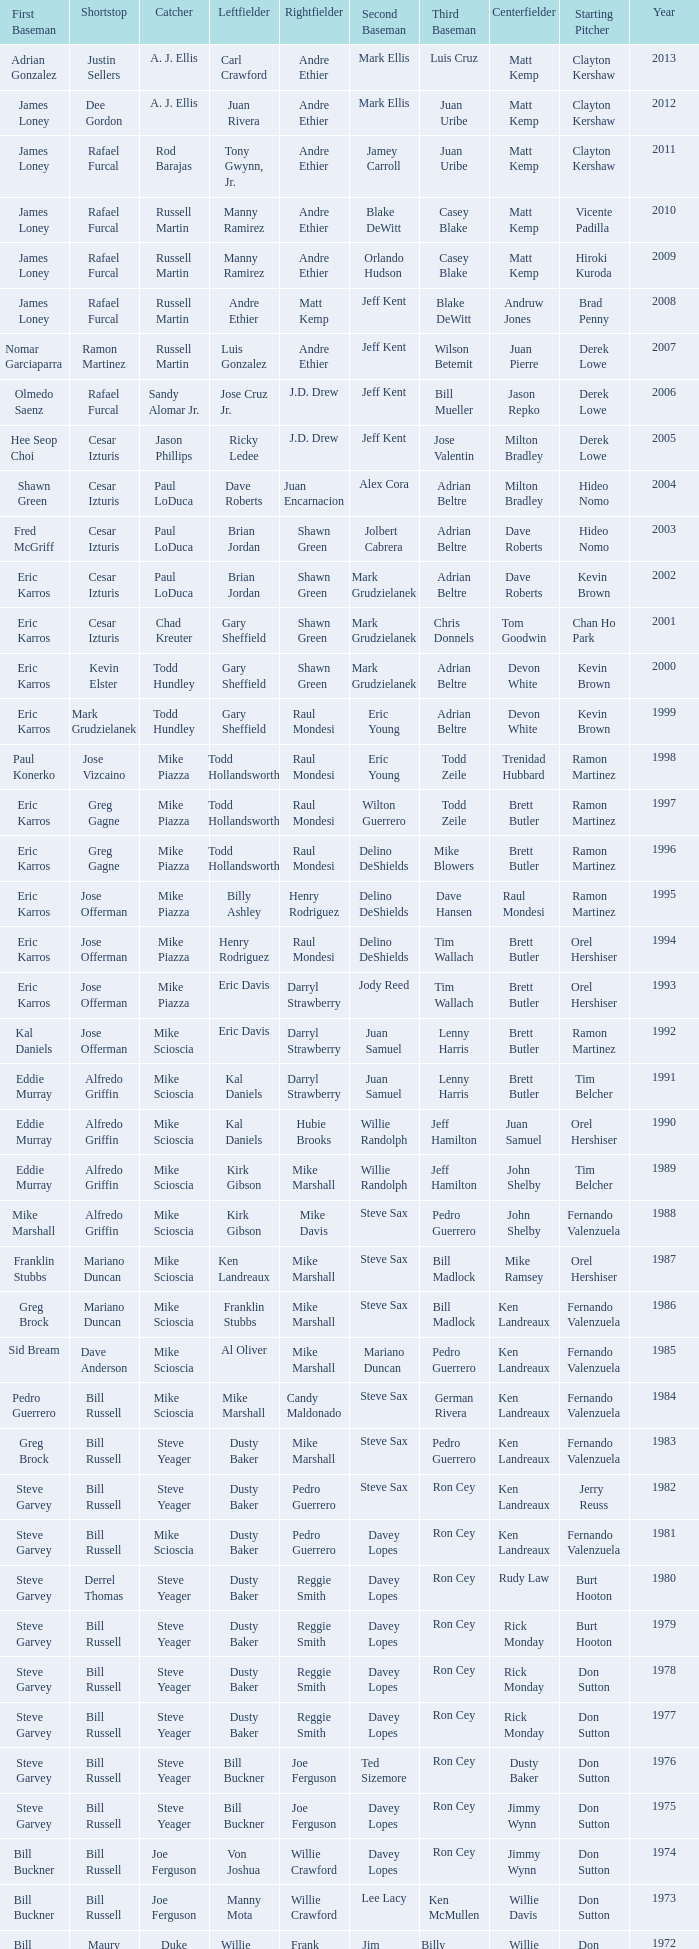Who was the RF when the SP was vicente padilla? Andre Ethier. 